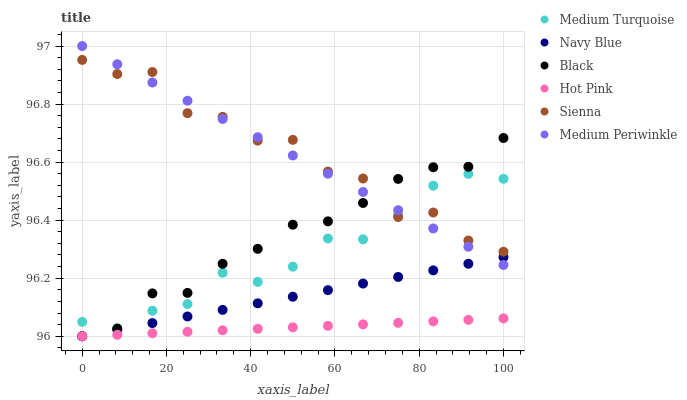Does Hot Pink have the minimum area under the curve?
Answer yes or no. Yes. Does Sienna have the maximum area under the curve?
Answer yes or no. Yes. Does Medium Periwinkle have the minimum area under the curve?
Answer yes or no. No. Does Medium Periwinkle have the maximum area under the curve?
Answer yes or no. No. Is Hot Pink the smoothest?
Answer yes or no. Yes. Is Sienna the roughest?
Answer yes or no. Yes. Is Medium Periwinkle the smoothest?
Answer yes or no. No. Is Medium Periwinkle the roughest?
Answer yes or no. No. Does Navy Blue have the lowest value?
Answer yes or no. Yes. Does Medium Periwinkle have the lowest value?
Answer yes or no. No. Does Medium Periwinkle have the highest value?
Answer yes or no. Yes. Does Hot Pink have the highest value?
Answer yes or no. No. Is Hot Pink less than Sienna?
Answer yes or no. Yes. Is Medium Turquoise greater than Navy Blue?
Answer yes or no. Yes. Does Black intersect Medium Turquoise?
Answer yes or no. Yes. Is Black less than Medium Turquoise?
Answer yes or no. No. Is Black greater than Medium Turquoise?
Answer yes or no. No. Does Hot Pink intersect Sienna?
Answer yes or no. No. 